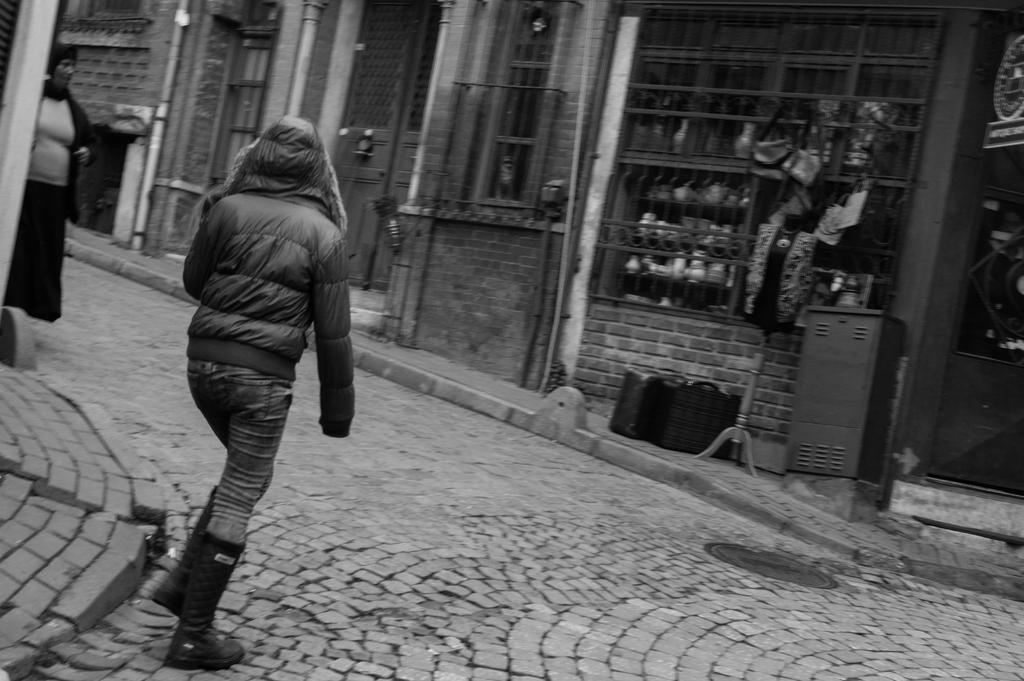How many people are present in the image? There are two people in the image. What is the position of the people in the image? The people are on the ground. What can be seen in the background of the image? There is a building and objects visible in the background of the image. What type of dime is the person reading in the image? There is no dime or reading activity present in the image. How many trees can be seen in the image? There is no mention of trees in the provided facts, so we cannot determine the number of trees in the image. 